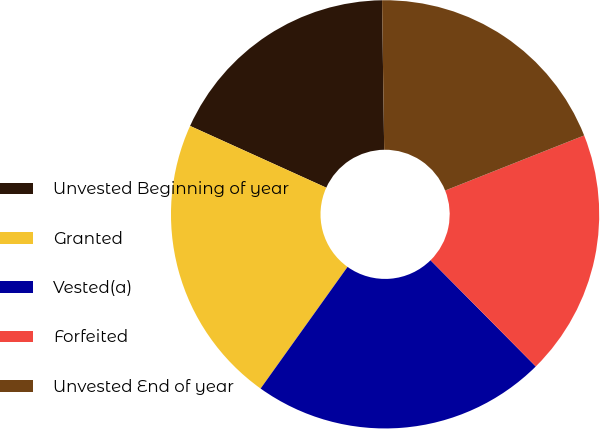<chart> <loc_0><loc_0><loc_500><loc_500><pie_chart><fcel>Unvested Beginning of year<fcel>Granted<fcel>Vested(a)<fcel>Forfeited<fcel>Unvested End of year<nl><fcel>18.0%<fcel>21.9%<fcel>22.3%<fcel>18.58%<fcel>19.22%<nl></chart> 